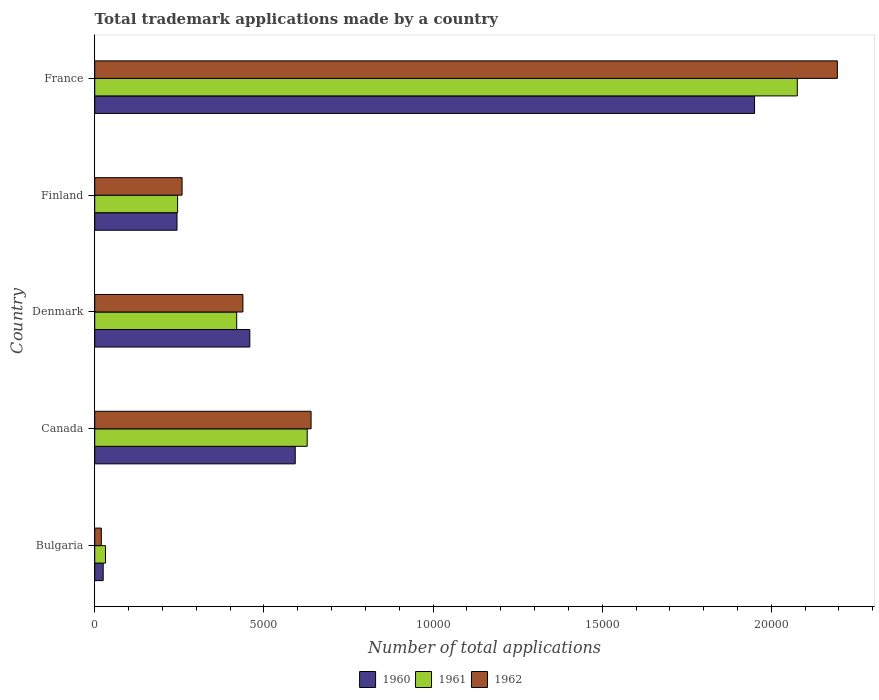How many different coloured bars are there?
Keep it short and to the point. 3. How many groups of bars are there?
Offer a very short reply. 5. Are the number of bars per tick equal to the number of legend labels?
Keep it short and to the point. Yes. How many bars are there on the 2nd tick from the bottom?
Keep it short and to the point. 3. What is the label of the 4th group of bars from the top?
Give a very brief answer. Canada. What is the number of applications made by in 1960 in Bulgaria?
Provide a succinct answer. 250. Across all countries, what is the maximum number of applications made by in 1961?
Give a very brief answer. 2.08e+04. Across all countries, what is the minimum number of applications made by in 1960?
Your answer should be compact. 250. In which country was the number of applications made by in 1962 minimum?
Offer a very short reply. Bulgaria. What is the total number of applications made by in 1960 in the graph?
Ensure brevity in your answer.  3.27e+04. What is the difference between the number of applications made by in 1961 in Finland and that in France?
Ensure brevity in your answer.  -1.83e+04. What is the difference between the number of applications made by in 1961 in Canada and the number of applications made by in 1962 in Bulgaria?
Keep it short and to the point. 6086. What is the average number of applications made by in 1962 per country?
Provide a succinct answer. 7100.8. What is the difference between the number of applications made by in 1960 and number of applications made by in 1962 in Canada?
Keep it short and to the point. -468. What is the ratio of the number of applications made by in 1962 in Finland to that in France?
Offer a terse response. 0.12. Is the number of applications made by in 1960 in Canada less than that in France?
Provide a succinct answer. Yes. Is the difference between the number of applications made by in 1960 in Bulgaria and Canada greater than the difference between the number of applications made by in 1962 in Bulgaria and Canada?
Provide a succinct answer. Yes. What is the difference between the highest and the second highest number of applications made by in 1960?
Keep it short and to the point. 1.36e+04. What is the difference between the highest and the lowest number of applications made by in 1960?
Provide a succinct answer. 1.93e+04. In how many countries, is the number of applications made by in 1962 greater than the average number of applications made by in 1962 taken over all countries?
Provide a short and direct response. 1. Is the sum of the number of applications made by in 1961 in Bulgaria and Finland greater than the maximum number of applications made by in 1960 across all countries?
Offer a very short reply. No. What does the 3rd bar from the top in Canada represents?
Your answer should be compact. 1960. What does the 3rd bar from the bottom in Finland represents?
Keep it short and to the point. 1962. Are the values on the major ticks of X-axis written in scientific E-notation?
Provide a short and direct response. No. Where does the legend appear in the graph?
Offer a terse response. Bottom center. How many legend labels are there?
Your response must be concise. 3. What is the title of the graph?
Keep it short and to the point. Total trademark applications made by a country. Does "1977" appear as one of the legend labels in the graph?
Your answer should be very brief. No. What is the label or title of the X-axis?
Provide a short and direct response. Number of total applications. What is the label or title of the Y-axis?
Your response must be concise. Country. What is the Number of total applications in 1960 in Bulgaria?
Your response must be concise. 250. What is the Number of total applications of 1961 in Bulgaria?
Your answer should be compact. 318. What is the Number of total applications in 1962 in Bulgaria?
Offer a terse response. 195. What is the Number of total applications of 1960 in Canada?
Your response must be concise. 5927. What is the Number of total applications in 1961 in Canada?
Offer a terse response. 6281. What is the Number of total applications of 1962 in Canada?
Your answer should be very brief. 6395. What is the Number of total applications of 1960 in Denmark?
Ensure brevity in your answer.  4584. What is the Number of total applications in 1961 in Denmark?
Make the answer very short. 4196. What is the Number of total applications in 1962 in Denmark?
Make the answer very short. 4380. What is the Number of total applications in 1960 in Finland?
Give a very brief answer. 2432. What is the Number of total applications in 1961 in Finland?
Provide a succinct answer. 2450. What is the Number of total applications in 1962 in Finland?
Your answer should be compact. 2582. What is the Number of total applications of 1960 in France?
Ensure brevity in your answer.  1.95e+04. What is the Number of total applications in 1961 in France?
Your answer should be compact. 2.08e+04. What is the Number of total applications in 1962 in France?
Offer a very short reply. 2.20e+04. Across all countries, what is the maximum Number of total applications in 1960?
Keep it short and to the point. 1.95e+04. Across all countries, what is the maximum Number of total applications in 1961?
Make the answer very short. 2.08e+04. Across all countries, what is the maximum Number of total applications of 1962?
Provide a short and direct response. 2.20e+04. Across all countries, what is the minimum Number of total applications in 1960?
Provide a succinct answer. 250. Across all countries, what is the minimum Number of total applications of 1961?
Offer a very short reply. 318. Across all countries, what is the minimum Number of total applications in 1962?
Make the answer very short. 195. What is the total Number of total applications of 1960 in the graph?
Provide a short and direct response. 3.27e+04. What is the total Number of total applications in 1961 in the graph?
Offer a terse response. 3.40e+04. What is the total Number of total applications in 1962 in the graph?
Your answer should be very brief. 3.55e+04. What is the difference between the Number of total applications in 1960 in Bulgaria and that in Canada?
Give a very brief answer. -5677. What is the difference between the Number of total applications of 1961 in Bulgaria and that in Canada?
Offer a very short reply. -5963. What is the difference between the Number of total applications in 1962 in Bulgaria and that in Canada?
Provide a succinct answer. -6200. What is the difference between the Number of total applications in 1960 in Bulgaria and that in Denmark?
Your answer should be very brief. -4334. What is the difference between the Number of total applications of 1961 in Bulgaria and that in Denmark?
Your response must be concise. -3878. What is the difference between the Number of total applications in 1962 in Bulgaria and that in Denmark?
Offer a terse response. -4185. What is the difference between the Number of total applications in 1960 in Bulgaria and that in Finland?
Offer a terse response. -2182. What is the difference between the Number of total applications of 1961 in Bulgaria and that in Finland?
Make the answer very short. -2132. What is the difference between the Number of total applications in 1962 in Bulgaria and that in Finland?
Your answer should be compact. -2387. What is the difference between the Number of total applications of 1960 in Bulgaria and that in France?
Provide a succinct answer. -1.93e+04. What is the difference between the Number of total applications in 1961 in Bulgaria and that in France?
Make the answer very short. -2.04e+04. What is the difference between the Number of total applications of 1962 in Bulgaria and that in France?
Give a very brief answer. -2.18e+04. What is the difference between the Number of total applications in 1960 in Canada and that in Denmark?
Keep it short and to the point. 1343. What is the difference between the Number of total applications of 1961 in Canada and that in Denmark?
Make the answer very short. 2085. What is the difference between the Number of total applications in 1962 in Canada and that in Denmark?
Offer a terse response. 2015. What is the difference between the Number of total applications in 1960 in Canada and that in Finland?
Your response must be concise. 3495. What is the difference between the Number of total applications of 1961 in Canada and that in Finland?
Ensure brevity in your answer.  3831. What is the difference between the Number of total applications in 1962 in Canada and that in Finland?
Keep it short and to the point. 3813. What is the difference between the Number of total applications in 1960 in Canada and that in France?
Your response must be concise. -1.36e+04. What is the difference between the Number of total applications of 1961 in Canada and that in France?
Provide a short and direct response. -1.45e+04. What is the difference between the Number of total applications of 1962 in Canada and that in France?
Provide a succinct answer. -1.56e+04. What is the difference between the Number of total applications of 1960 in Denmark and that in Finland?
Provide a succinct answer. 2152. What is the difference between the Number of total applications of 1961 in Denmark and that in Finland?
Provide a succinct answer. 1746. What is the difference between the Number of total applications in 1962 in Denmark and that in Finland?
Provide a short and direct response. 1798. What is the difference between the Number of total applications in 1960 in Denmark and that in France?
Provide a short and direct response. -1.49e+04. What is the difference between the Number of total applications of 1961 in Denmark and that in France?
Give a very brief answer. -1.66e+04. What is the difference between the Number of total applications in 1962 in Denmark and that in France?
Give a very brief answer. -1.76e+04. What is the difference between the Number of total applications in 1960 in Finland and that in France?
Ensure brevity in your answer.  -1.71e+04. What is the difference between the Number of total applications in 1961 in Finland and that in France?
Ensure brevity in your answer.  -1.83e+04. What is the difference between the Number of total applications of 1962 in Finland and that in France?
Offer a very short reply. -1.94e+04. What is the difference between the Number of total applications of 1960 in Bulgaria and the Number of total applications of 1961 in Canada?
Keep it short and to the point. -6031. What is the difference between the Number of total applications of 1960 in Bulgaria and the Number of total applications of 1962 in Canada?
Your answer should be very brief. -6145. What is the difference between the Number of total applications in 1961 in Bulgaria and the Number of total applications in 1962 in Canada?
Provide a succinct answer. -6077. What is the difference between the Number of total applications of 1960 in Bulgaria and the Number of total applications of 1961 in Denmark?
Provide a short and direct response. -3946. What is the difference between the Number of total applications in 1960 in Bulgaria and the Number of total applications in 1962 in Denmark?
Provide a succinct answer. -4130. What is the difference between the Number of total applications of 1961 in Bulgaria and the Number of total applications of 1962 in Denmark?
Make the answer very short. -4062. What is the difference between the Number of total applications in 1960 in Bulgaria and the Number of total applications in 1961 in Finland?
Offer a terse response. -2200. What is the difference between the Number of total applications in 1960 in Bulgaria and the Number of total applications in 1962 in Finland?
Provide a short and direct response. -2332. What is the difference between the Number of total applications in 1961 in Bulgaria and the Number of total applications in 1962 in Finland?
Offer a very short reply. -2264. What is the difference between the Number of total applications in 1960 in Bulgaria and the Number of total applications in 1961 in France?
Your answer should be compact. -2.05e+04. What is the difference between the Number of total applications of 1960 in Bulgaria and the Number of total applications of 1962 in France?
Provide a short and direct response. -2.17e+04. What is the difference between the Number of total applications of 1961 in Bulgaria and the Number of total applications of 1962 in France?
Your answer should be very brief. -2.16e+04. What is the difference between the Number of total applications in 1960 in Canada and the Number of total applications in 1961 in Denmark?
Make the answer very short. 1731. What is the difference between the Number of total applications of 1960 in Canada and the Number of total applications of 1962 in Denmark?
Keep it short and to the point. 1547. What is the difference between the Number of total applications in 1961 in Canada and the Number of total applications in 1962 in Denmark?
Give a very brief answer. 1901. What is the difference between the Number of total applications of 1960 in Canada and the Number of total applications of 1961 in Finland?
Your response must be concise. 3477. What is the difference between the Number of total applications of 1960 in Canada and the Number of total applications of 1962 in Finland?
Offer a terse response. 3345. What is the difference between the Number of total applications in 1961 in Canada and the Number of total applications in 1962 in Finland?
Give a very brief answer. 3699. What is the difference between the Number of total applications in 1960 in Canada and the Number of total applications in 1961 in France?
Make the answer very short. -1.48e+04. What is the difference between the Number of total applications of 1960 in Canada and the Number of total applications of 1962 in France?
Give a very brief answer. -1.60e+04. What is the difference between the Number of total applications in 1961 in Canada and the Number of total applications in 1962 in France?
Offer a very short reply. -1.57e+04. What is the difference between the Number of total applications in 1960 in Denmark and the Number of total applications in 1961 in Finland?
Give a very brief answer. 2134. What is the difference between the Number of total applications in 1960 in Denmark and the Number of total applications in 1962 in Finland?
Keep it short and to the point. 2002. What is the difference between the Number of total applications in 1961 in Denmark and the Number of total applications in 1962 in Finland?
Provide a short and direct response. 1614. What is the difference between the Number of total applications of 1960 in Denmark and the Number of total applications of 1961 in France?
Provide a succinct answer. -1.62e+04. What is the difference between the Number of total applications in 1960 in Denmark and the Number of total applications in 1962 in France?
Your response must be concise. -1.74e+04. What is the difference between the Number of total applications of 1961 in Denmark and the Number of total applications of 1962 in France?
Provide a succinct answer. -1.78e+04. What is the difference between the Number of total applications in 1960 in Finland and the Number of total applications in 1961 in France?
Your response must be concise. -1.83e+04. What is the difference between the Number of total applications in 1960 in Finland and the Number of total applications in 1962 in France?
Your answer should be compact. -1.95e+04. What is the difference between the Number of total applications of 1961 in Finland and the Number of total applications of 1962 in France?
Your answer should be very brief. -1.95e+04. What is the average Number of total applications of 1960 per country?
Provide a succinct answer. 6539.4. What is the average Number of total applications in 1961 per country?
Provide a short and direct response. 6802.6. What is the average Number of total applications in 1962 per country?
Ensure brevity in your answer.  7100.8. What is the difference between the Number of total applications in 1960 and Number of total applications in 1961 in Bulgaria?
Provide a succinct answer. -68. What is the difference between the Number of total applications in 1960 and Number of total applications in 1962 in Bulgaria?
Give a very brief answer. 55. What is the difference between the Number of total applications of 1961 and Number of total applications of 1962 in Bulgaria?
Your answer should be compact. 123. What is the difference between the Number of total applications in 1960 and Number of total applications in 1961 in Canada?
Make the answer very short. -354. What is the difference between the Number of total applications in 1960 and Number of total applications in 1962 in Canada?
Your answer should be very brief. -468. What is the difference between the Number of total applications in 1961 and Number of total applications in 1962 in Canada?
Provide a succinct answer. -114. What is the difference between the Number of total applications of 1960 and Number of total applications of 1961 in Denmark?
Keep it short and to the point. 388. What is the difference between the Number of total applications in 1960 and Number of total applications in 1962 in Denmark?
Your answer should be very brief. 204. What is the difference between the Number of total applications of 1961 and Number of total applications of 1962 in Denmark?
Offer a very short reply. -184. What is the difference between the Number of total applications in 1960 and Number of total applications in 1961 in Finland?
Your answer should be compact. -18. What is the difference between the Number of total applications in 1960 and Number of total applications in 1962 in Finland?
Offer a terse response. -150. What is the difference between the Number of total applications in 1961 and Number of total applications in 1962 in Finland?
Make the answer very short. -132. What is the difference between the Number of total applications of 1960 and Number of total applications of 1961 in France?
Provide a succinct answer. -1264. What is the difference between the Number of total applications in 1960 and Number of total applications in 1962 in France?
Offer a very short reply. -2448. What is the difference between the Number of total applications of 1961 and Number of total applications of 1962 in France?
Give a very brief answer. -1184. What is the ratio of the Number of total applications in 1960 in Bulgaria to that in Canada?
Ensure brevity in your answer.  0.04. What is the ratio of the Number of total applications of 1961 in Bulgaria to that in Canada?
Provide a short and direct response. 0.05. What is the ratio of the Number of total applications in 1962 in Bulgaria to that in Canada?
Your answer should be compact. 0.03. What is the ratio of the Number of total applications in 1960 in Bulgaria to that in Denmark?
Offer a terse response. 0.05. What is the ratio of the Number of total applications in 1961 in Bulgaria to that in Denmark?
Give a very brief answer. 0.08. What is the ratio of the Number of total applications in 1962 in Bulgaria to that in Denmark?
Provide a short and direct response. 0.04. What is the ratio of the Number of total applications of 1960 in Bulgaria to that in Finland?
Offer a terse response. 0.1. What is the ratio of the Number of total applications in 1961 in Bulgaria to that in Finland?
Your answer should be compact. 0.13. What is the ratio of the Number of total applications of 1962 in Bulgaria to that in Finland?
Keep it short and to the point. 0.08. What is the ratio of the Number of total applications in 1960 in Bulgaria to that in France?
Offer a very short reply. 0.01. What is the ratio of the Number of total applications in 1961 in Bulgaria to that in France?
Keep it short and to the point. 0.02. What is the ratio of the Number of total applications of 1962 in Bulgaria to that in France?
Offer a terse response. 0.01. What is the ratio of the Number of total applications in 1960 in Canada to that in Denmark?
Offer a terse response. 1.29. What is the ratio of the Number of total applications in 1961 in Canada to that in Denmark?
Offer a very short reply. 1.5. What is the ratio of the Number of total applications in 1962 in Canada to that in Denmark?
Your answer should be compact. 1.46. What is the ratio of the Number of total applications in 1960 in Canada to that in Finland?
Give a very brief answer. 2.44. What is the ratio of the Number of total applications in 1961 in Canada to that in Finland?
Provide a succinct answer. 2.56. What is the ratio of the Number of total applications in 1962 in Canada to that in Finland?
Offer a terse response. 2.48. What is the ratio of the Number of total applications in 1960 in Canada to that in France?
Make the answer very short. 0.3. What is the ratio of the Number of total applications of 1961 in Canada to that in France?
Keep it short and to the point. 0.3. What is the ratio of the Number of total applications of 1962 in Canada to that in France?
Offer a very short reply. 0.29. What is the ratio of the Number of total applications in 1960 in Denmark to that in Finland?
Provide a succinct answer. 1.88. What is the ratio of the Number of total applications of 1961 in Denmark to that in Finland?
Give a very brief answer. 1.71. What is the ratio of the Number of total applications in 1962 in Denmark to that in Finland?
Your response must be concise. 1.7. What is the ratio of the Number of total applications of 1960 in Denmark to that in France?
Offer a terse response. 0.23. What is the ratio of the Number of total applications in 1961 in Denmark to that in France?
Provide a short and direct response. 0.2. What is the ratio of the Number of total applications of 1962 in Denmark to that in France?
Ensure brevity in your answer.  0.2. What is the ratio of the Number of total applications in 1960 in Finland to that in France?
Offer a terse response. 0.12. What is the ratio of the Number of total applications of 1961 in Finland to that in France?
Your answer should be compact. 0.12. What is the ratio of the Number of total applications of 1962 in Finland to that in France?
Your answer should be compact. 0.12. What is the difference between the highest and the second highest Number of total applications in 1960?
Keep it short and to the point. 1.36e+04. What is the difference between the highest and the second highest Number of total applications in 1961?
Offer a terse response. 1.45e+04. What is the difference between the highest and the second highest Number of total applications of 1962?
Your response must be concise. 1.56e+04. What is the difference between the highest and the lowest Number of total applications of 1960?
Provide a short and direct response. 1.93e+04. What is the difference between the highest and the lowest Number of total applications of 1961?
Make the answer very short. 2.04e+04. What is the difference between the highest and the lowest Number of total applications of 1962?
Your answer should be very brief. 2.18e+04. 